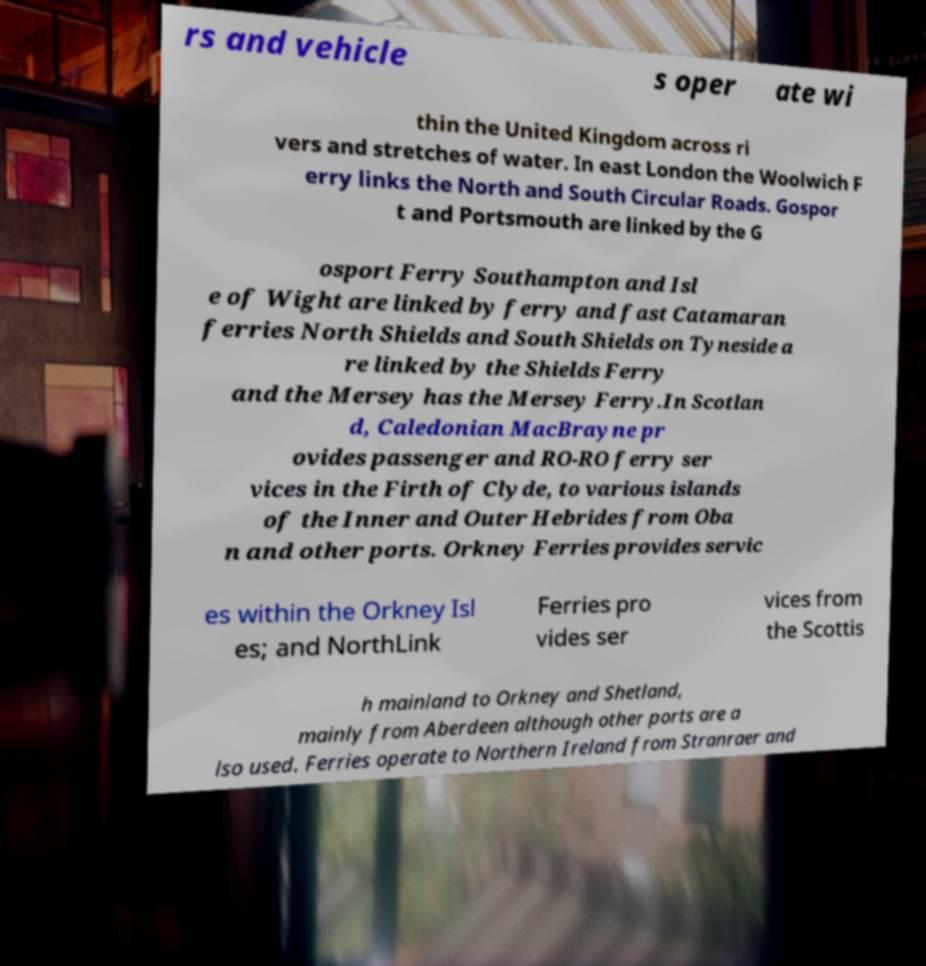Can you accurately transcribe the text from the provided image for me? rs and vehicle s oper ate wi thin the United Kingdom across ri vers and stretches of water. In east London the Woolwich F erry links the North and South Circular Roads. Gospor t and Portsmouth are linked by the G osport Ferry Southampton and Isl e of Wight are linked by ferry and fast Catamaran ferries North Shields and South Shields on Tyneside a re linked by the Shields Ferry and the Mersey has the Mersey Ferry.In Scotlan d, Caledonian MacBrayne pr ovides passenger and RO-RO ferry ser vices in the Firth of Clyde, to various islands of the Inner and Outer Hebrides from Oba n and other ports. Orkney Ferries provides servic es within the Orkney Isl es; and NorthLink Ferries pro vides ser vices from the Scottis h mainland to Orkney and Shetland, mainly from Aberdeen although other ports are a lso used. Ferries operate to Northern Ireland from Stranraer and 